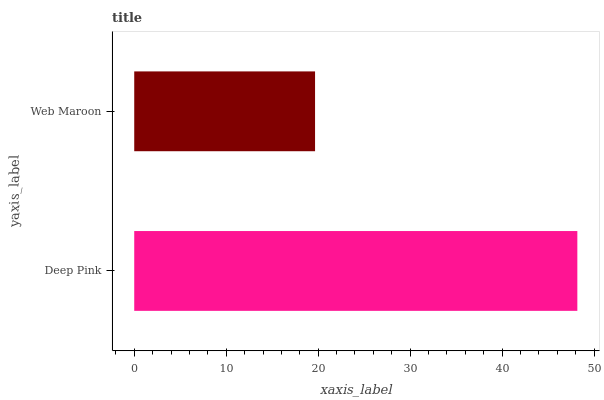Is Web Maroon the minimum?
Answer yes or no. Yes. Is Deep Pink the maximum?
Answer yes or no. Yes. Is Web Maroon the maximum?
Answer yes or no. No. Is Deep Pink greater than Web Maroon?
Answer yes or no. Yes. Is Web Maroon less than Deep Pink?
Answer yes or no. Yes. Is Web Maroon greater than Deep Pink?
Answer yes or no. No. Is Deep Pink less than Web Maroon?
Answer yes or no. No. Is Deep Pink the high median?
Answer yes or no. Yes. Is Web Maroon the low median?
Answer yes or no. Yes. Is Web Maroon the high median?
Answer yes or no. No. Is Deep Pink the low median?
Answer yes or no. No. 